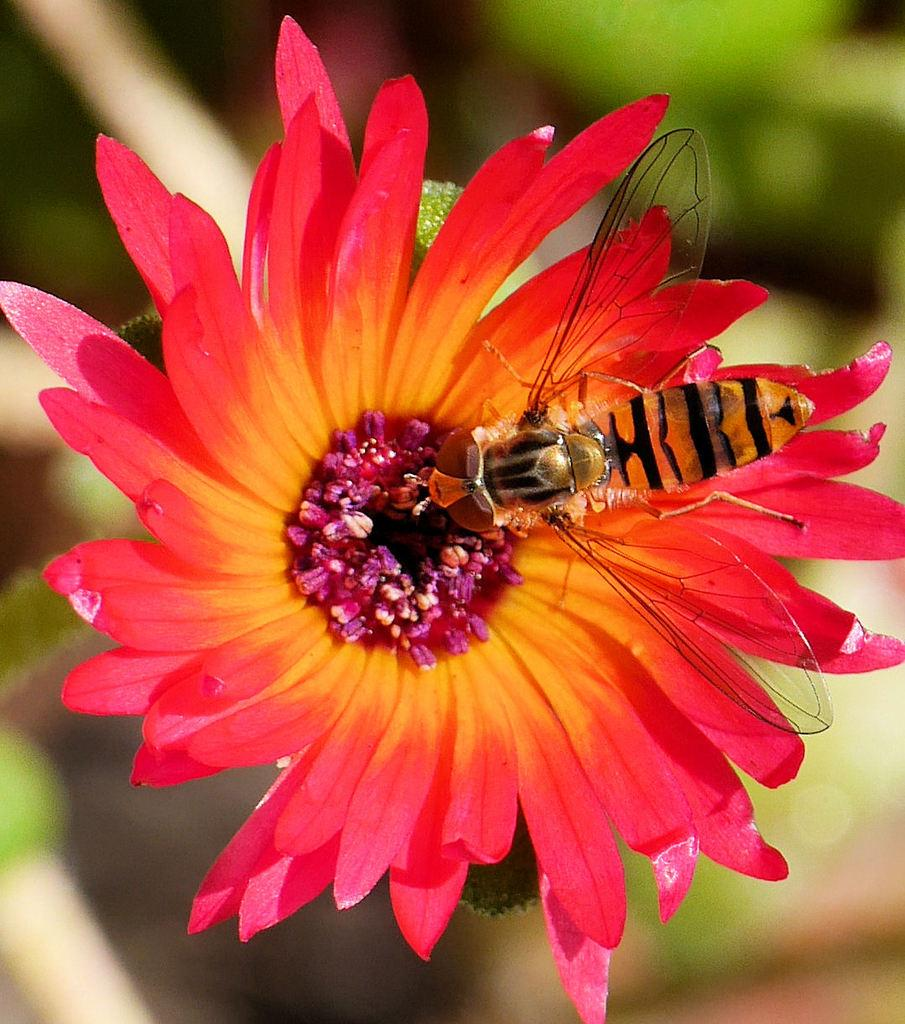What is the main subject of the image? There is a bee in the image. Where is the bee located? The bee is on a flower. Can you describe the flower? The flower has pink and yellow petals. What can be observed about the background of the image? The background of the image is blurred. What type of store can be seen in the background of the image? There is no store present in the image; the background is blurred. What is the bee discussing with the flower in the image? Bees and flowers do not engage in discussions; the bee is on the flower to collect nectar and pollen. 